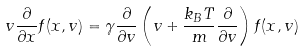Convert formula to latex. <formula><loc_0><loc_0><loc_500><loc_500>v \frac { \partial } { \partial x } f ( x , v ) = \gamma \frac { \partial } { \partial v } \left ( v + \frac { k _ { B } T } { m } \frac { \partial } { \partial v } \right ) f ( x , v )</formula> 